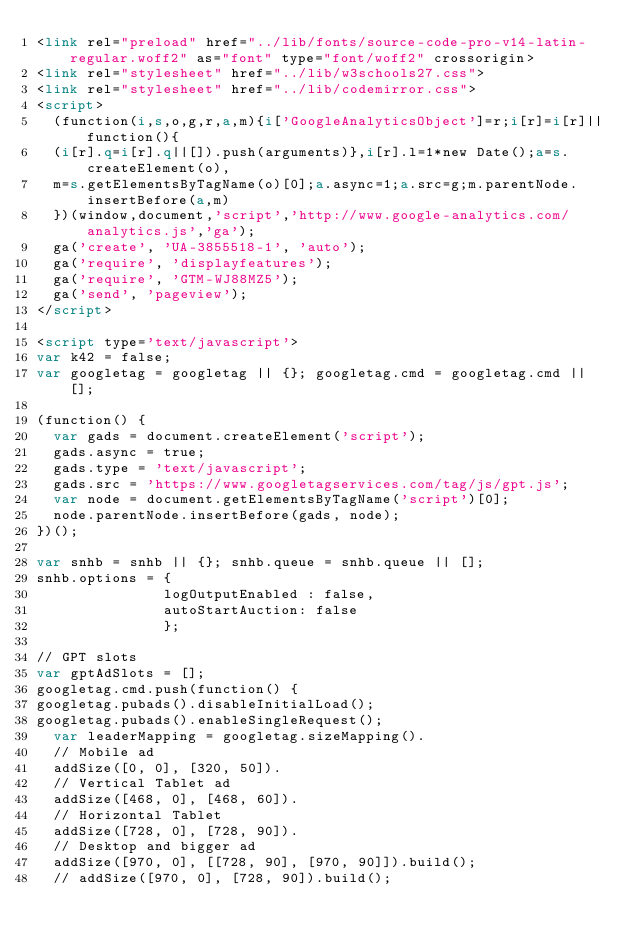Convert code to text. <code><loc_0><loc_0><loc_500><loc_500><_HTML_><link rel="preload" href="../lib/fonts/source-code-pro-v14-latin-regular.woff2" as="font" type="font/woff2" crossorigin> 
<link rel="stylesheet" href="../lib/w3schools27.css">
<link rel="stylesheet" href="../lib/codemirror.css">
<script>
  (function(i,s,o,g,r,a,m){i['GoogleAnalyticsObject']=r;i[r]=i[r]||function(){
  (i[r].q=i[r].q||[]).push(arguments)},i[r].l=1*new Date();a=s.createElement(o),
  m=s.getElementsByTagName(o)[0];a.async=1;a.src=g;m.parentNode.insertBefore(a,m)
  })(window,document,'script','http://www.google-analytics.com/analytics.js','ga');
  ga('create', 'UA-3855518-1', 'auto');
  ga('require', 'displayfeatures');
  ga('require', 'GTM-WJ88MZ5');
  ga('send', 'pageview');
</script>

<script type='text/javascript'>
var k42 = false;
var googletag = googletag || {}; googletag.cmd = googletag.cmd || [];

(function() {
  var gads = document.createElement('script');
  gads.async = true;
  gads.type = 'text/javascript';
  gads.src = 'https://www.googletagservices.com/tag/js/gpt.js';
  var node = document.getElementsByTagName('script')[0];
  node.parentNode.insertBefore(gads, node);
})();

var snhb = snhb || {}; snhb.queue = snhb.queue || [];
snhb.options = {
               logOutputEnabled : false,
               autoStartAuction: false
               };

// GPT slots
var gptAdSlots = [];
googletag.cmd.push(function() {
googletag.pubads().disableInitialLoad();               
googletag.pubads().enableSingleRequest();
  var leaderMapping = googletag.sizeMapping().
  // Mobile ad
  addSize([0, 0], [320, 50]). 
  // Vertical Tablet ad
  addSize([468, 0], [468, 60]). 
  // Horizontal Tablet
  addSize([728, 0], [728, 90]).
  // Desktop and bigger ad
  addSize([970, 0], [[728, 90], [970, 90]]).build();
  // addSize([970, 0], [728, 90]).build();</code> 